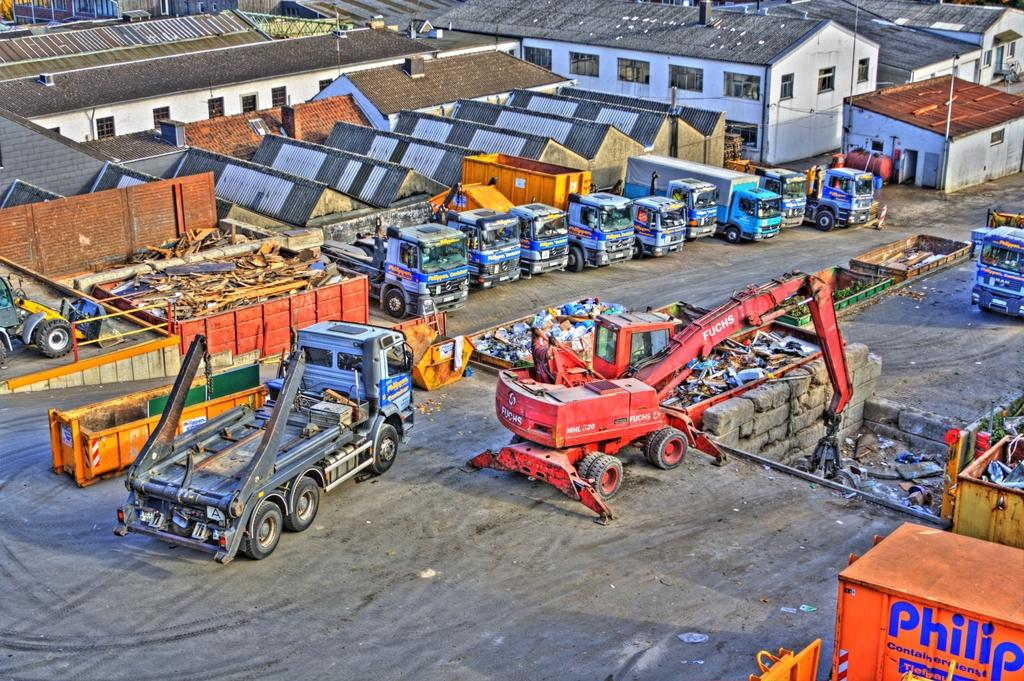What type of structures can be seen in the image? There are houses in the image. What feature is visible on the houses? There are windows visible in the image. What else can be seen in the image besides houses? Vehicles and containers are visible in the image. What type of material is used for the wall in the image? There is a brick wall in the image. What are the poles used for in the image? The purpose of the poles in the image is not specified, but they could be for support or utilities. What type of rings can be seen on the trees in the image? There are no trees or rings present in the image. 